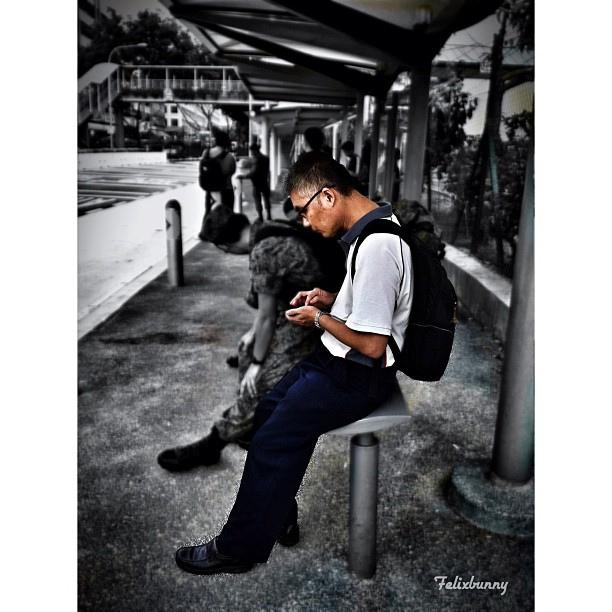Where is the man storing his things? backpack 